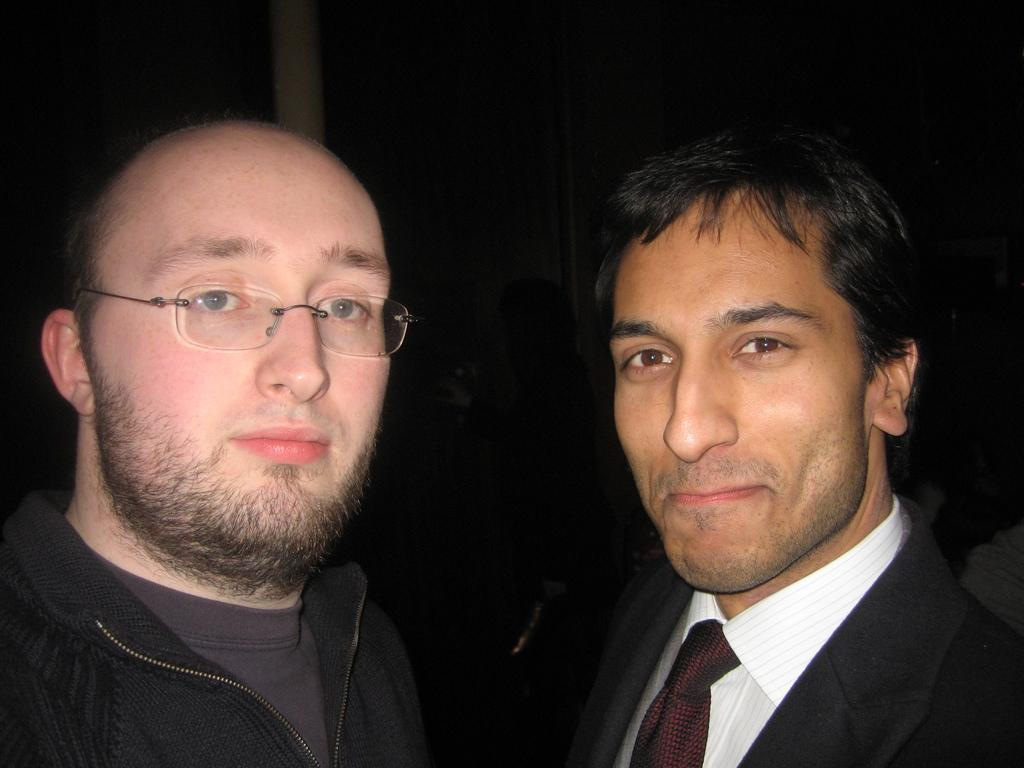What is the person in the image wearing on their upper body? The person is wearing a black coat in the image. What accessory is the person wearing? The person is wearing spectacles. How many people are in the image? There are two people in the image. What is the second person wearing on their upper body? The second person is wearing a white shirt and a black blazer. What is the color of the background in the image? The background of the image is dark. How many kittens are sitting on the person's lap in the image? There are no kittens present in the image. What type of cream is being used by the person in the image? There is no cream visible or mentioned in the image. 